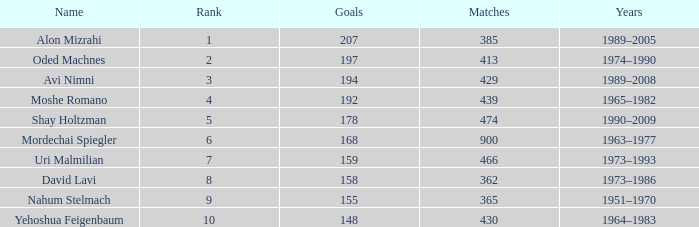What is the Rank of the player with 362 Matches? 8.0. I'm looking to parse the entire table for insights. Could you assist me with that? {'header': ['Name', 'Rank', 'Goals', 'Matches', 'Years'], 'rows': [['Alon Mizrahi', '1', '207', '385', '1989–2005'], ['Oded Machnes', '2', '197', '413', '1974–1990'], ['Avi Nimni', '3', '194', '429', '1989–2008'], ['Moshe Romano', '4', '192', '439', '1965–1982'], ['Shay Holtzman', '5', '178', '474', '1990–2009'], ['Mordechai Spiegler', '6', '168', '900', '1963–1977'], ['Uri Malmilian', '7', '159', '466', '1973–1993'], ['David Lavi', '8', '158', '362', '1973–1986'], ['Nahum Stelmach', '9', '155', '365', '1951–1970'], ['Yehoshua Feigenbaum', '10', '148', '430', '1964–1983']]} 